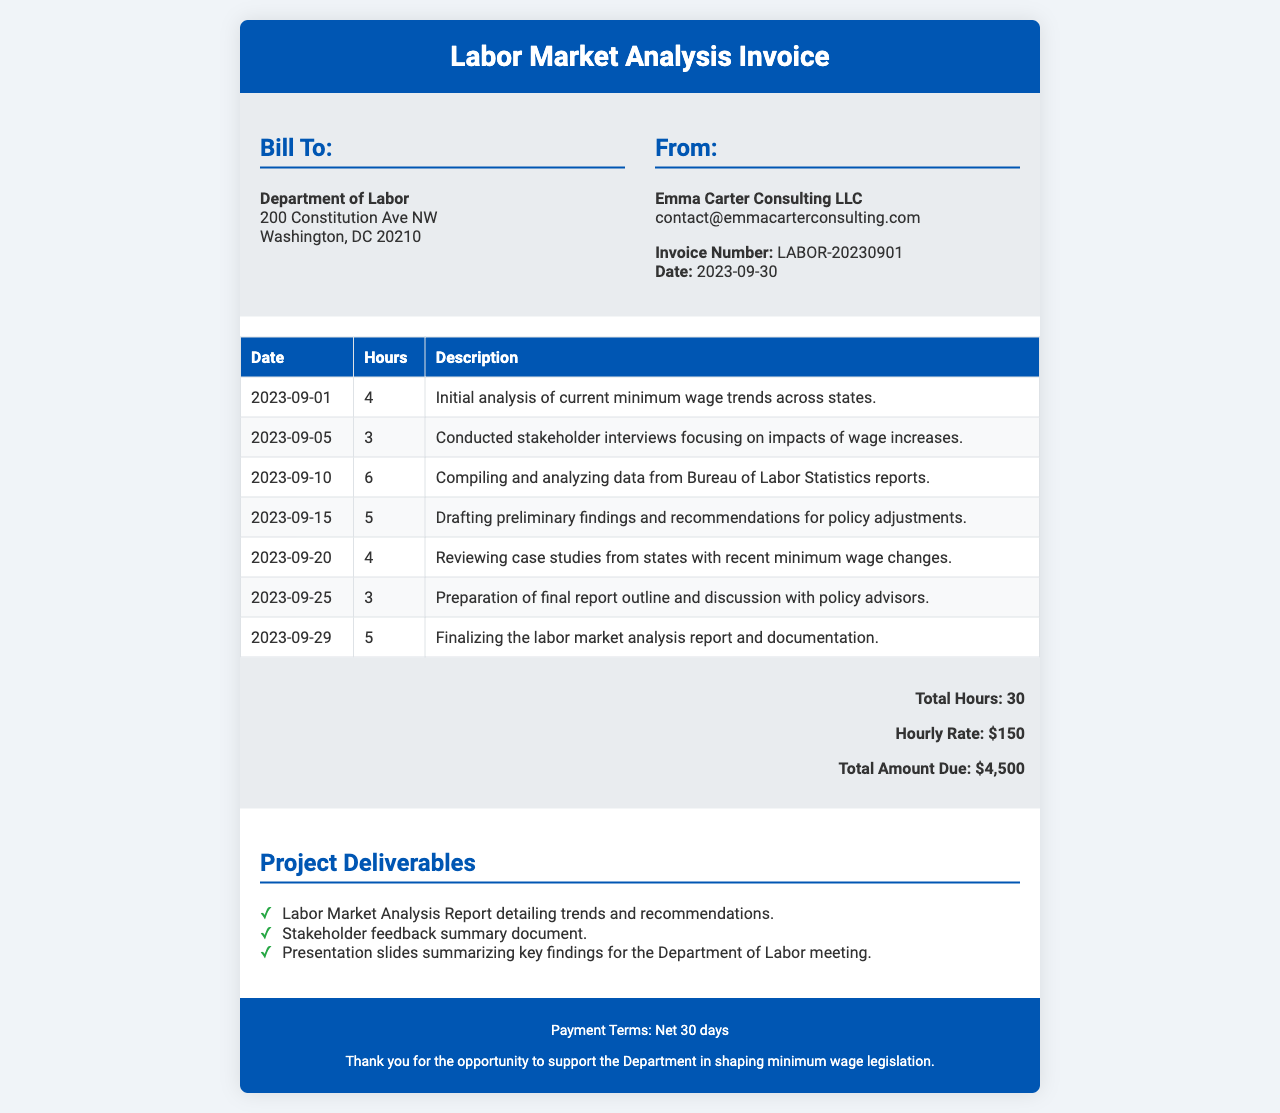What is the invoice number? The invoice number is listed in the consultant info section of the document.
Answer: LABOR-20230901 What is the total amount due? The total amount due is calculated from the hourly rate times total hours worked, presented at the bottom of the invoice.
Answer: $4,500 How many hours were worked in total? The total hours are summed up from the hours table in the document.
Answer: 30 What is the date of the invoice? The date is specified in the consultant info section of the document.
Answer: 2023-09-30 What project deliverable summarizes the key findings? The deliverable that summarizes the key findings is mentioned in the project deliverables section.
Answer: Presentation slides summarizing key findings for the Department of Labor meeting What is the hourly rate charged? The hourly rate is indicated in the total section of the invoice document.
Answer: $150 What was one of the tasks performed on September 10? This task can be found in the hours table by looking at the entry for September 10.
Answer: Compiling and analyzing data from Bureau of Labor Statistics reports Who is billing the Department of Labor? The billing entity is mentioned in the "From" section of the document.
Answer: Emma Carter Consulting LLC What are the payment terms? The payment terms are stated at the bottom of the document.
Answer: Net 30 days 